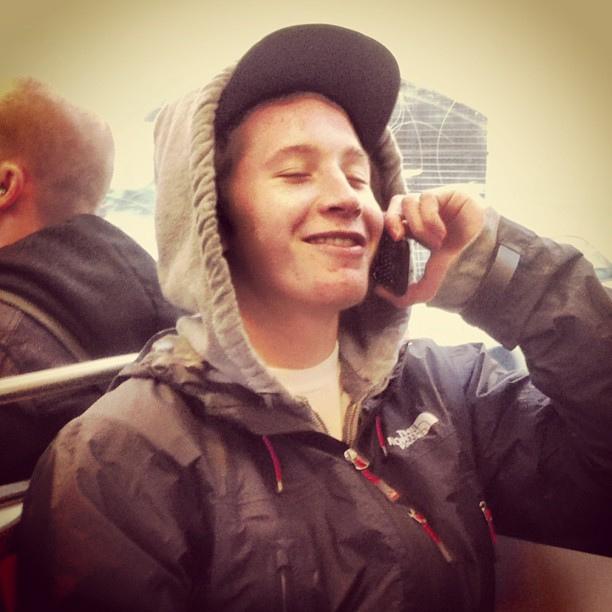Is the boy happy?
Keep it brief. Yes. Is the weather warm or chilly?
Quick response, please. Chilly. Which hand is the kid holding the phone with?
Quick response, please. Left. 